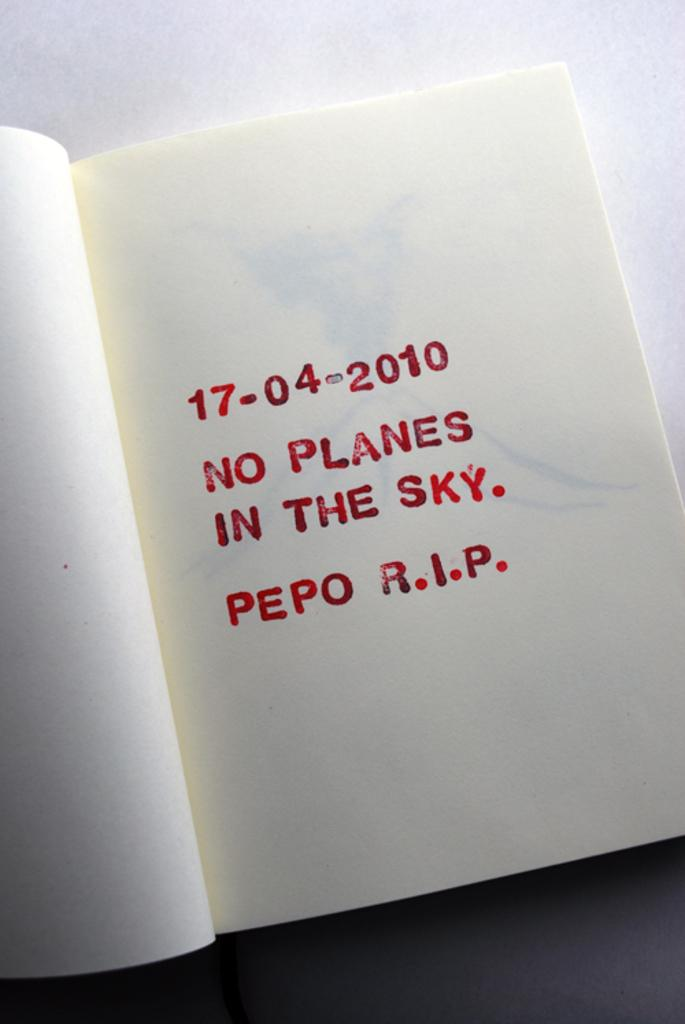<image>
Provide a brief description of the given image. 17-04-2010 NO PLANES IN THE SKY. PEPO R.I.P. 